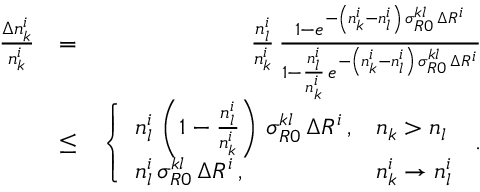<formula> <loc_0><loc_0><loc_500><loc_500>\begin{array} { r l r } { \frac { \Delta n _ { k } ^ { i } } { n _ { k } ^ { i } } } & { = } & { \frac { n _ { l } ^ { i } } { n _ { k } ^ { i } } \, \frac { 1 - e ^ { - \left ( n _ { k } ^ { i } - n _ { l } ^ { i } \right ) \, \sigma _ { R 0 } ^ { k l } \, \Delta R ^ { i } } } { 1 - \frac { n _ { l } ^ { i } } { n _ { k } ^ { i } } \, e ^ { - \left ( n _ { k } ^ { i } - n _ { l } ^ { i } \right ) \, \sigma _ { R 0 } ^ { k l } \, \Delta R ^ { i } } } } \\ & { \leq } & { \left \{ \begin{array} { l l } { n _ { l } ^ { i } \, \left ( 1 - \frac { n _ { l } ^ { i } } { n _ { k } ^ { i } } \right ) \, \sigma _ { R 0 } ^ { k l } \, \Delta R ^ { i } \, , } & { n _ { k } > n _ { l } } \\ { n _ { l } ^ { i } \, \sigma _ { R 0 } ^ { k l } \, \Delta R ^ { i } \, , } & { n _ { k } ^ { i } \rightarrow n _ { l } ^ { i } } \end{array} \, . } \end{array}</formula> 